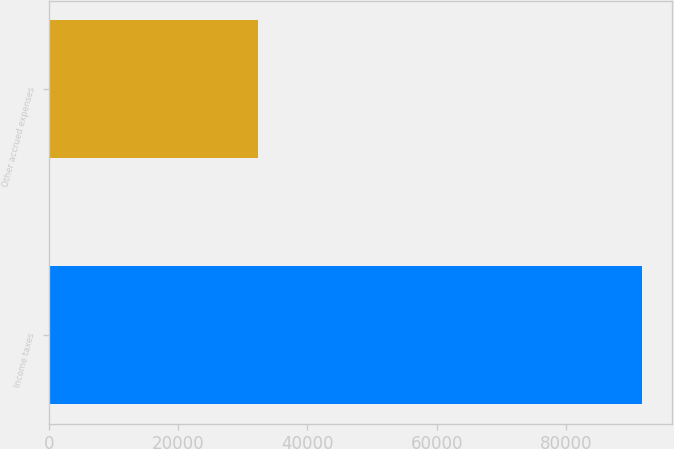Convert chart to OTSL. <chart><loc_0><loc_0><loc_500><loc_500><bar_chart><fcel>Income taxes<fcel>Other accrued expenses<nl><fcel>91771<fcel>32280<nl></chart> 